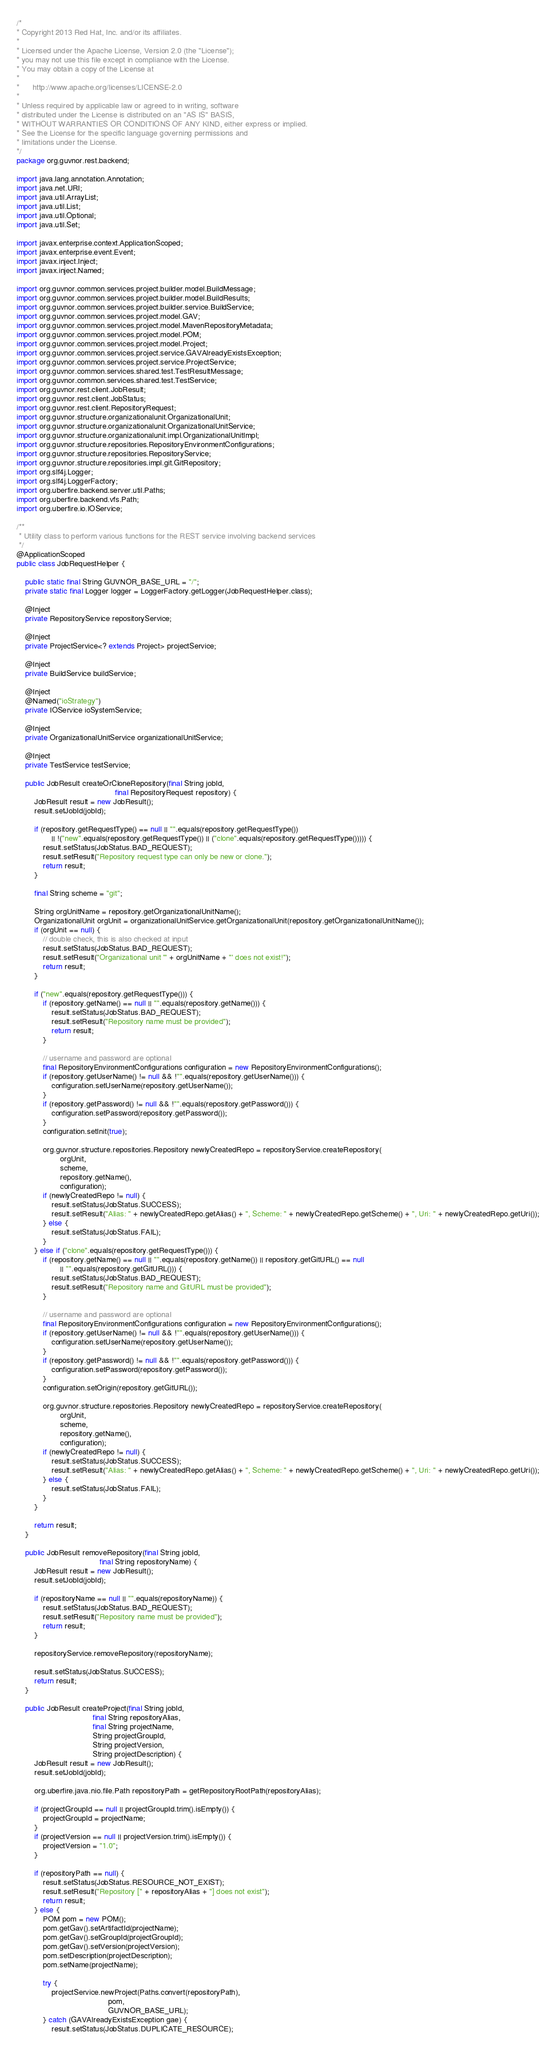Convert code to text. <code><loc_0><loc_0><loc_500><loc_500><_Java_>/*
* Copyright 2013 Red Hat, Inc. and/or its affiliates.
*
* Licensed under the Apache License, Version 2.0 (the "License");
* you may not use this file except in compliance with the License.
* You may obtain a copy of the License at
*
*      http://www.apache.org/licenses/LICENSE-2.0
*
* Unless required by applicable law or agreed to in writing, software
* distributed under the License is distributed on an "AS IS" BASIS,
* WITHOUT WARRANTIES OR CONDITIONS OF ANY KIND, either express or implied.
* See the License for the specific language governing permissions and
* limitations under the License.
*/
package org.guvnor.rest.backend;

import java.lang.annotation.Annotation;
import java.net.URI;
import java.util.ArrayList;
import java.util.List;
import java.util.Optional;
import java.util.Set;

import javax.enterprise.context.ApplicationScoped;
import javax.enterprise.event.Event;
import javax.inject.Inject;
import javax.inject.Named;

import org.guvnor.common.services.project.builder.model.BuildMessage;
import org.guvnor.common.services.project.builder.model.BuildResults;
import org.guvnor.common.services.project.builder.service.BuildService;
import org.guvnor.common.services.project.model.GAV;
import org.guvnor.common.services.project.model.MavenRepositoryMetadata;
import org.guvnor.common.services.project.model.POM;
import org.guvnor.common.services.project.model.Project;
import org.guvnor.common.services.project.service.GAVAlreadyExistsException;
import org.guvnor.common.services.project.service.ProjectService;
import org.guvnor.common.services.shared.test.TestResultMessage;
import org.guvnor.common.services.shared.test.TestService;
import org.guvnor.rest.client.JobResult;
import org.guvnor.rest.client.JobStatus;
import org.guvnor.rest.client.RepositoryRequest;
import org.guvnor.structure.organizationalunit.OrganizationalUnit;
import org.guvnor.structure.organizationalunit.OrganizationalUnitService;
import org.guvnor.structure.organizationalunit.impl.OrganizationalUnitImpl;
import org.guvnor.structure.repositories.RepositoryEnvironmentConfigurations;
import org.guvnor.structure.repositories.RepositoryService;
import org.guvnor.structure.repositories.impl.git.GitRepository;
import org.slf4j.Logger;
import org.slf4j.LoggerFactory;
import org.uberfire.backend.server.util.Paths;
import org.uberfire.backend.vfs.Path;
import org.uberfire.io.IOService;

/**
 * Utility class to perform various functions for the REST service involving backend services
 */
@ApplicationScoped
public class JobRequestHelper {

    public static final String GUVNOR_BASE_URL = "/";
    private static final Logger logger = LoggerFactory.getLogger(JobRequestHelper.class);

    @Inject
    private RepositoryService repositoryService;

    @Inject
    private ProjectService<? extends Project> projectService;

    @Inject
    private BuildService buildService;

    @Inject
    @Named("ioStrategy")
    private IOService ioSystemService;

    @Inject
    private OrganizationalUnitService organizationalUnitService;

    @Inject
    private TestService testService;

    public JobResult createOrCloneRepository(final String jobId,
                                             final RepositoryRequest repository) {
        JobResult result = new JobResult();
        result.setJobId(jobId);

        if (repository.getRequestType() == null || "".equals(repository.getRequestType())
                || !("new".equals(repository.getRequestType()) || ("clone".equals(repository.getRequestType())))) {
            result.setStatus(JobStatus.BAD_REQUEST);
            result.setResult("Repository request type can only be new or clone.");
            return result;
        }

        final String scheme = "git";

        String orgUnitName = repository.getOrganizationalUnitName();
        OrganizationalUnit orgUnit = organizationalUnitService.getOrganizationalUnit(repository.getOrganizationalUnitName());
        if (orgUnit == null) {
            // double check, this is also checked at input
            result.setStatus(JobStatus.BAD_REQUEST);
            result.setResult("Organizational unit '" + orgUnitName + "' does not exist!");
            return result;
        }

        if ("new".equals(repository.getRequestType())) {
            if (repository.getName() == null || "".equals(repository.getName())) {
                result.setStatus(JobStatus.BAD_REQUEST);
                result.setResult("Repository name must be provided");
                return result;
            }

            // username and password are optional
            final RepositoryEnvironmentConfigurations configuration = new RepositoryEnvironmentConfigurations();
            if (repository.getUserName() != null && !"".equals(repository.getUserName())) {
                configuration.setUserName(repository.getUserName());
            }
            if (repository.getPassword() != null && !"".equals(repository.getPassword())) {
                configuration.setPassword(repository.getPassword());
            }
            configuration.setInit(true);

            org.guvnor.structure.repositories.Repository newlyCreatedRepo = repositoryService.createRepository(
                    orgUnit,
                    scheme,
                    repository.getName(),
                    configuration);
            if (newlyCreatedRepo != null) {
                result.setStatus(JobStatus.SUCCESS);
                result.setResult("Alias: " + newlyCreatedRepo.getAlias() + ", Scheme: " + newlyCreatedRepo.getScheme() + ", Uri: " + newlyCreatedRepo.getUri());
            } else {
                result.setStatus(JobStatus.FAIL);
            }
        } else if ("clone".equals(repository.getRequestType())) {
            if (repository.getName() == null || "".equals(repository.getName()) || repository.getGitURL() == null
                    || "".equals(repository.getGitURL())) {
                result.setStatus(JobStatus.BAD_REQUEST);
                result.setResult("Repository name and GitURL must be provided");
            }

            // username and password are optional
            final RepositoryEnvironmentConfigurations configuration = new RepositoryEnvironmentConfigurations();
            if (repository.getUserName() != null && !"".equals(repository.getUserName())) {
                configuration.setUserName(repository.getUserName());
            }
            if (repository.getPassword() != null && !"".equals(repository.getPassword())) {
                configuration.setPassword(repository.getPassword());
            }
            configuration.setOrigin(repository.getGitURL());

            org.guvnor.structure.repositories.Repository newlyCreatedRepo = repositoryService.createRepository(
                    orgUnit,
                    scheme,
                    repository.getName(),
                    configuration);
            if (newlyCreatedRepo != null) {
                result.setStatus(JobStatus.SUCCESS);
                result.setResult("Alias: " + newlyCreatedRepo.getAlias() + ", Scheme: " + newlyCreatedRepo.getScheme() + ", Uri: " + newlyCreatedRepo.getUri());
            } else {
                result.setStatus(JobStatus.FAIL);
            }
        }

        return result;
    }

    public JobResult removeRepository(final String jobId,
                                      final String repositoryName) {
        JobResult result = new JobResult();
        result.setJobId(jobId);

        if (repositoryName == null || "".equals(repositoryName)) {
            result.setStatus(JobStatus.BAD_REQUEST);
            result.setResult("Repository name must be provided");
            return result;
        }

        repositoryService.removeRepository(repositoryName);

        result.setStatus(JobStatus.SUCCESS);
        return result;
    }

    public JobResult createProject(final String jobId,
                                   final String repositoryAlias,
                                   final String projectName,
                                   String projectGroupId,
                                   String projectVersion,
                                   String projectDescription) {
        JobResult result = new JobResult();
        result.setJobId(jobId);

        org.uberfire.java.nio.file.Path repositoryPath = getRepositoryRootPath(repositoryAlias);

        if (projectGroupId == null || projectGroupId.trim().isEmpty()) {
            projectGroupId = projectName;
        }
        if (projectVersion == null || projectVersion.trim().isEmpty()) {
            projectVersion = "1.0";
        }

        if (repositoryPath == null) {
            result.setStatus(JobStatus.RESOURCE_NOT_EXIST);
            result.setResult("Repository [" + repositoryAlias + "] does not exist");
            return result;
        } else {
            POM pom = new POM();
            pom.getGav().setArtifactId(projectName);
            pom.getGav().setGroupId(projectGroupId);
            pom.getGav().setVersion(projectVersion);
            pom.setDescription(projectDescription);
            pom.setName(projectName);

            try {
                projectService.newProject(Paths.convert(repositoryPath),
                                          pom,
                                          GUVNOR_BASE_URL);
            } catch (GAVAlreadyExistsException gae) {
                result.setStatus(JobStatus.DUPLICATE_RESOURCE);</code> 